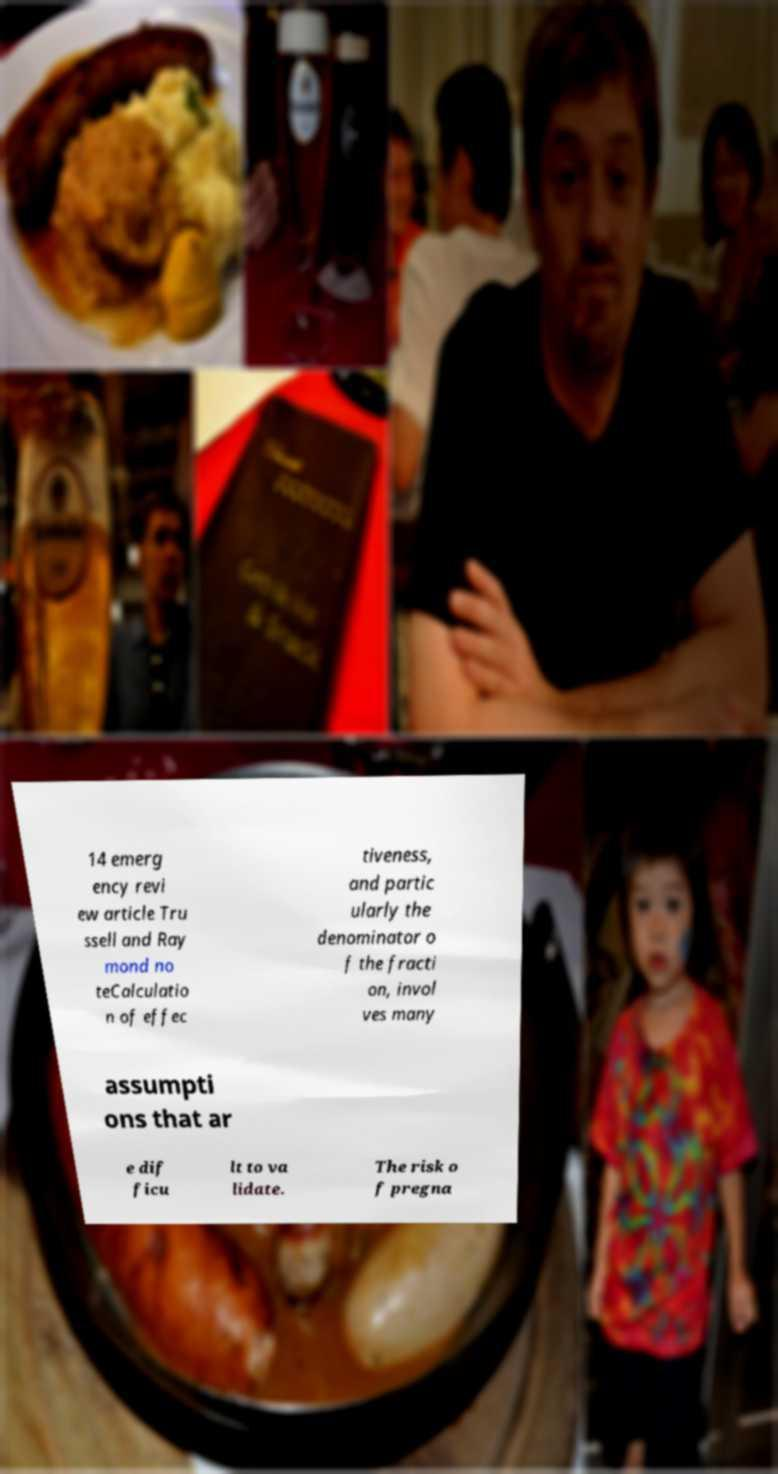Can you read and provide the text displayed in the image?This photo seems to have some interesting text. Can you extract and type it out for me? 14 emerg ency revi ew article Tru ssell and Ray mond no teCalculatio n of effec tiveness, and partic ularly the denominator o f the fracti on, invol ves many assumpti ons that ar e dif ficu lt to va lidate. The risk o f pregna 